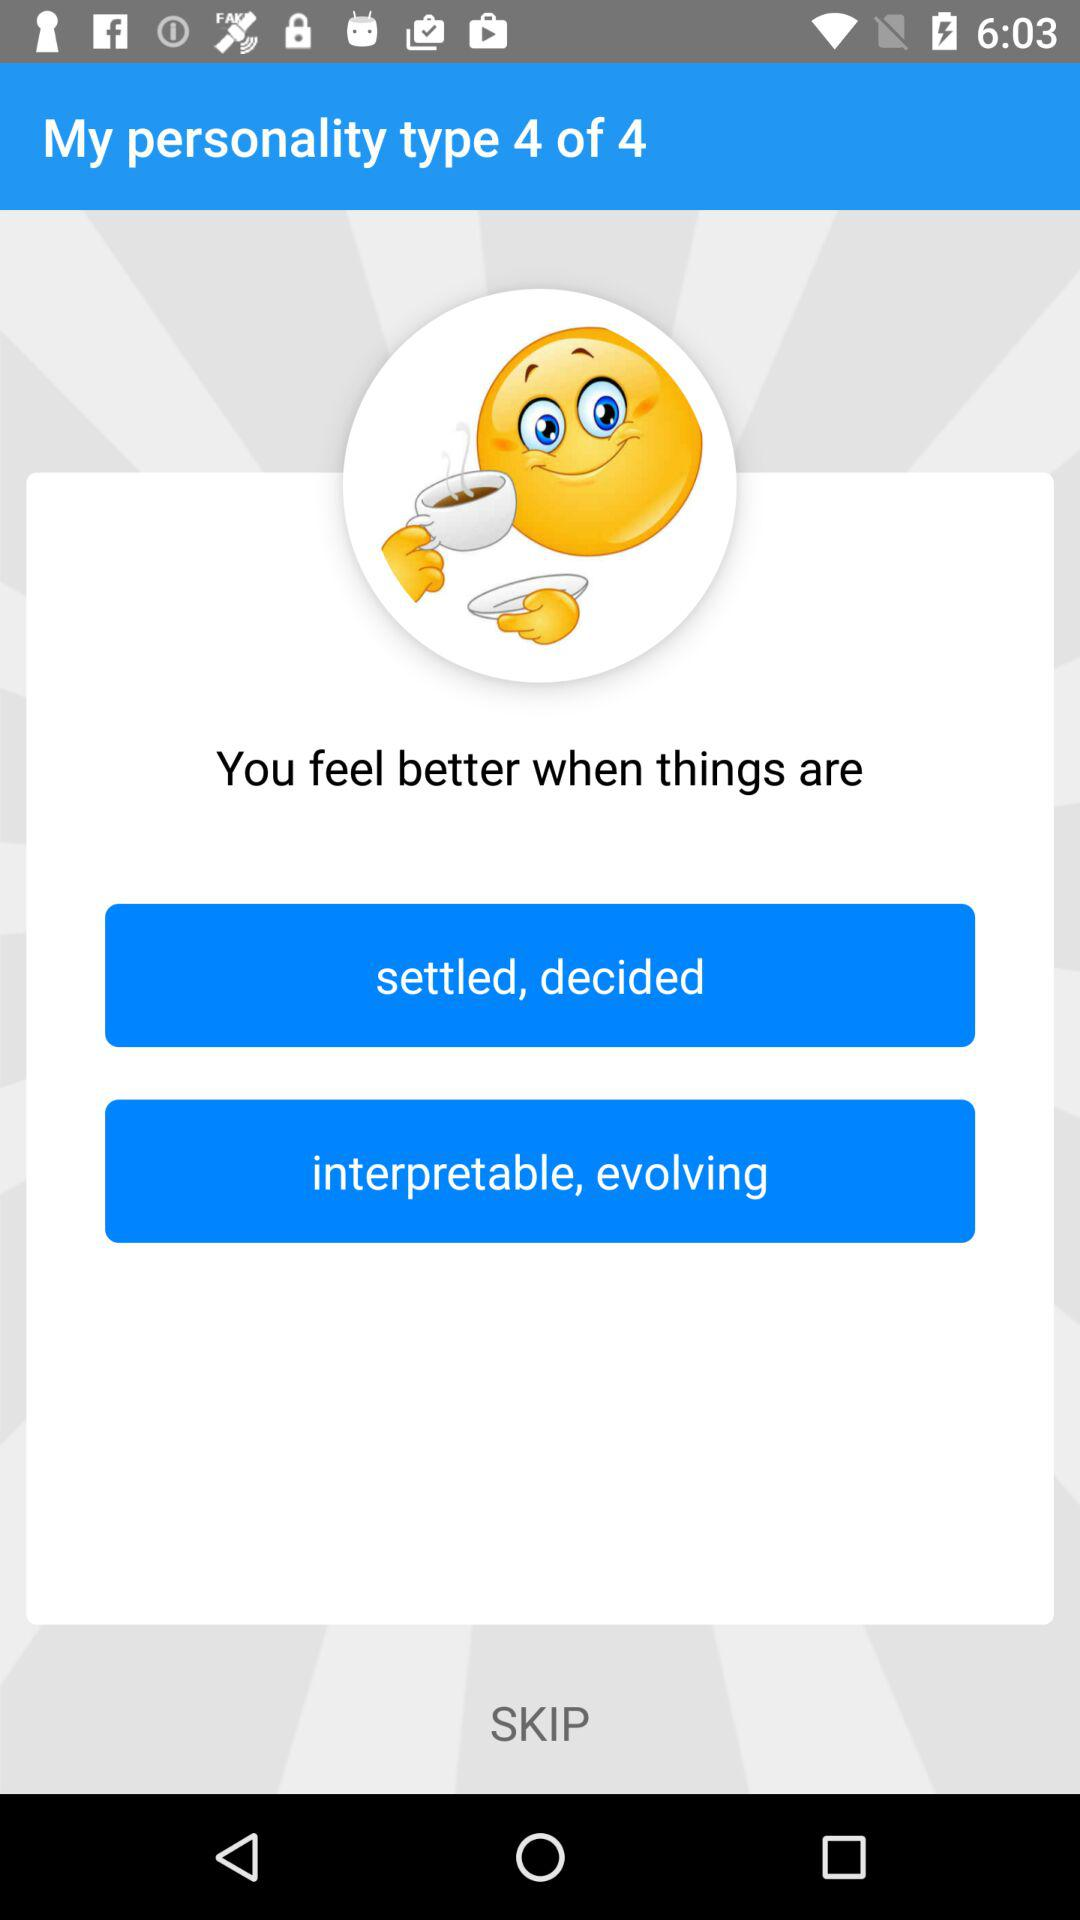Which personality type am I on? You are on personality type 4. 